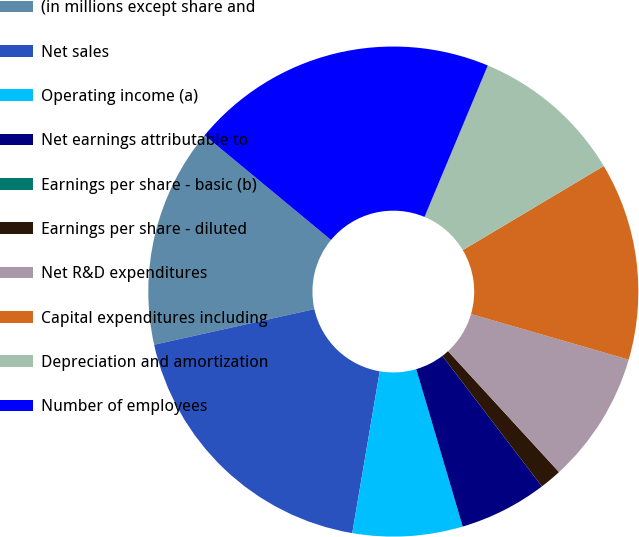Convert chart to OTSL. <chart><loc_0><loc_0><loc_500><loc_500><pie_chart><fcel>(in millions except share and<fcel>Net sales<fcel>Operating income (a)<fcel>Net earnings attributable to<fcel>Earnings per share - basic (b)<fcel>Earnings per share - diluted<fcel>Net R&D expenditures<fcel>Capital expenditures including<fcel>Depreciation and amortization<fcel>Number of employees<nl><fcel>14.49%<fcel>18.84%<fcel>7.25%<fcel>5.8%<fcel>0.0%<fcel>1.45%<fcel>8.7%<fcel>13.04%<fcel>10.14%<fcel>20.29%<nl></chart> 